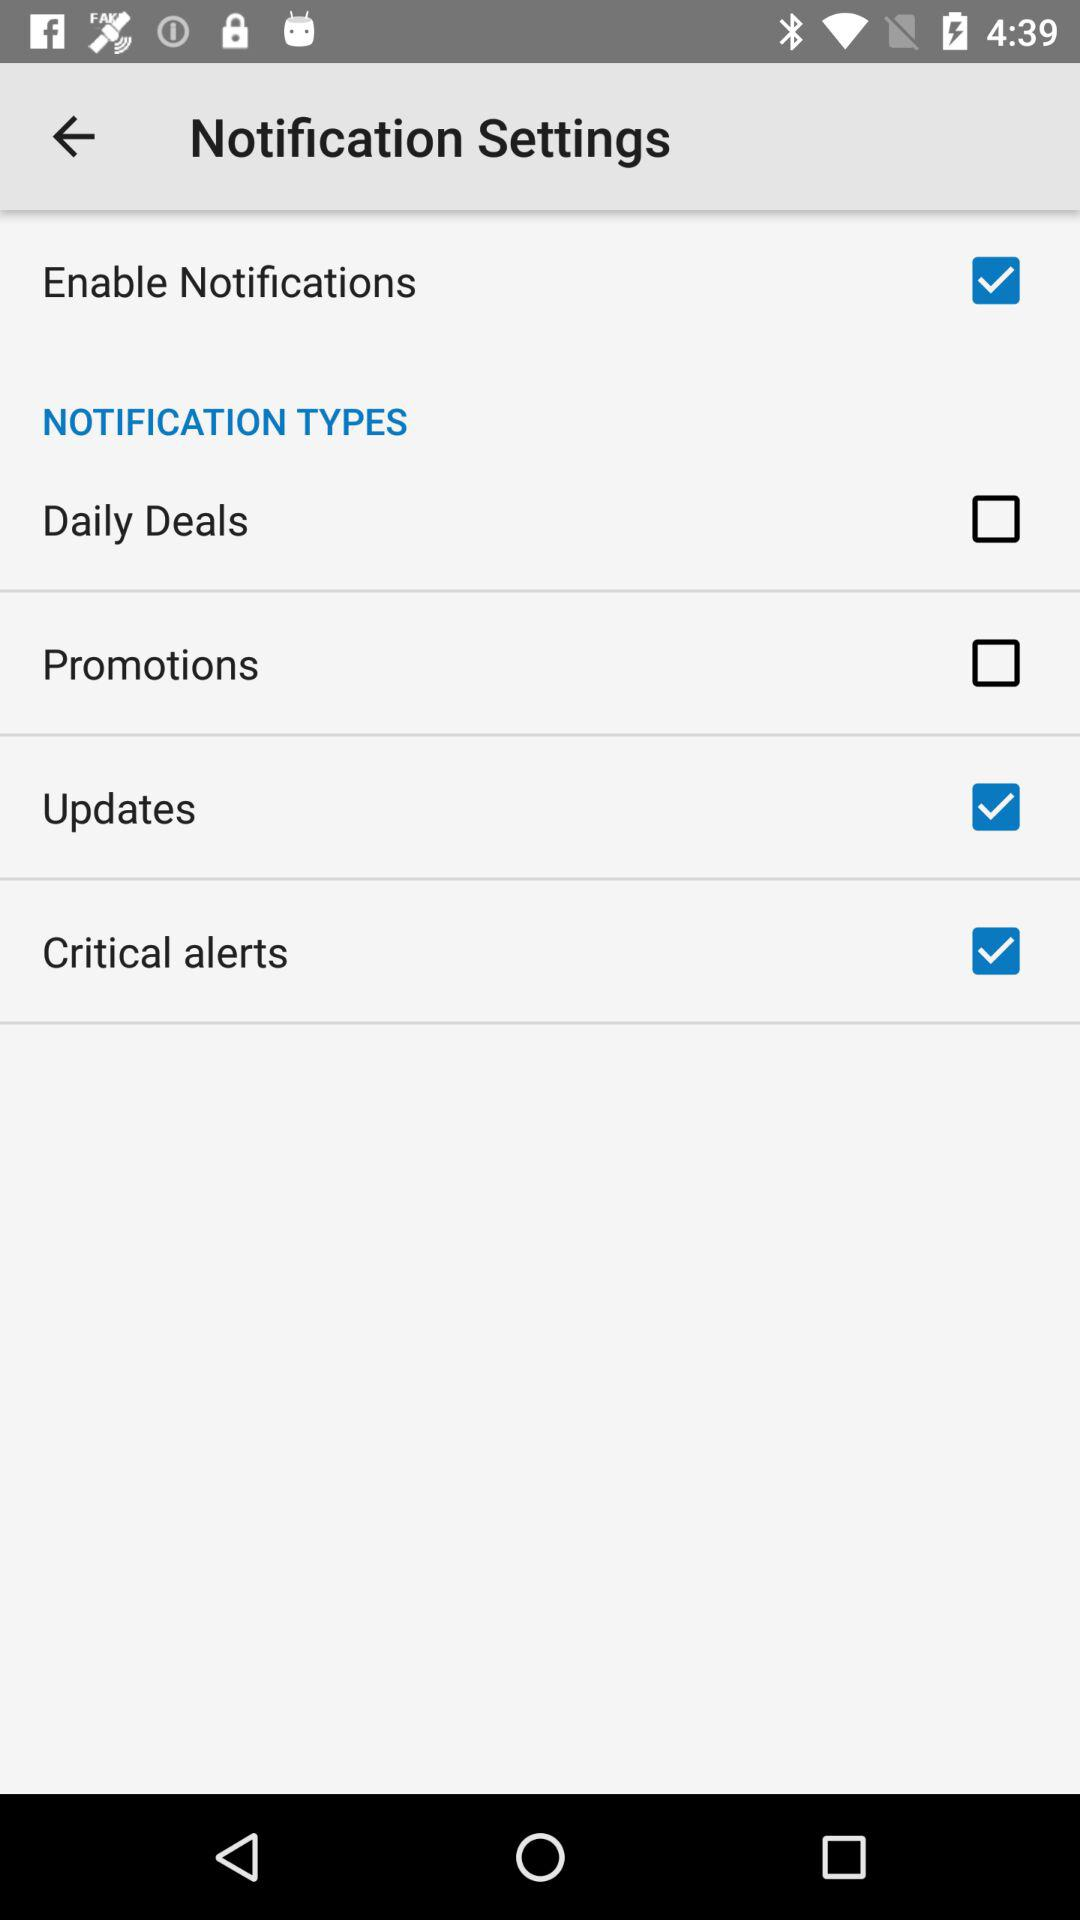What is the status of "Daily Deals"? The status is "off". 